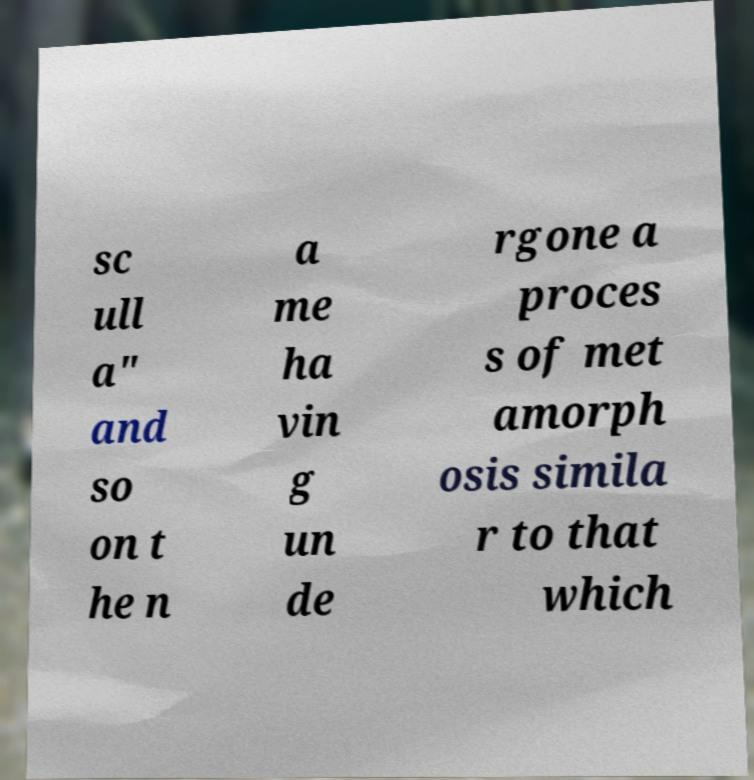Can you accurately transcribe the text from the provided image for me? sc ull a" and so on t he n a me ha vin g un de rgone a proces s of met amorph osis simila r to that which 